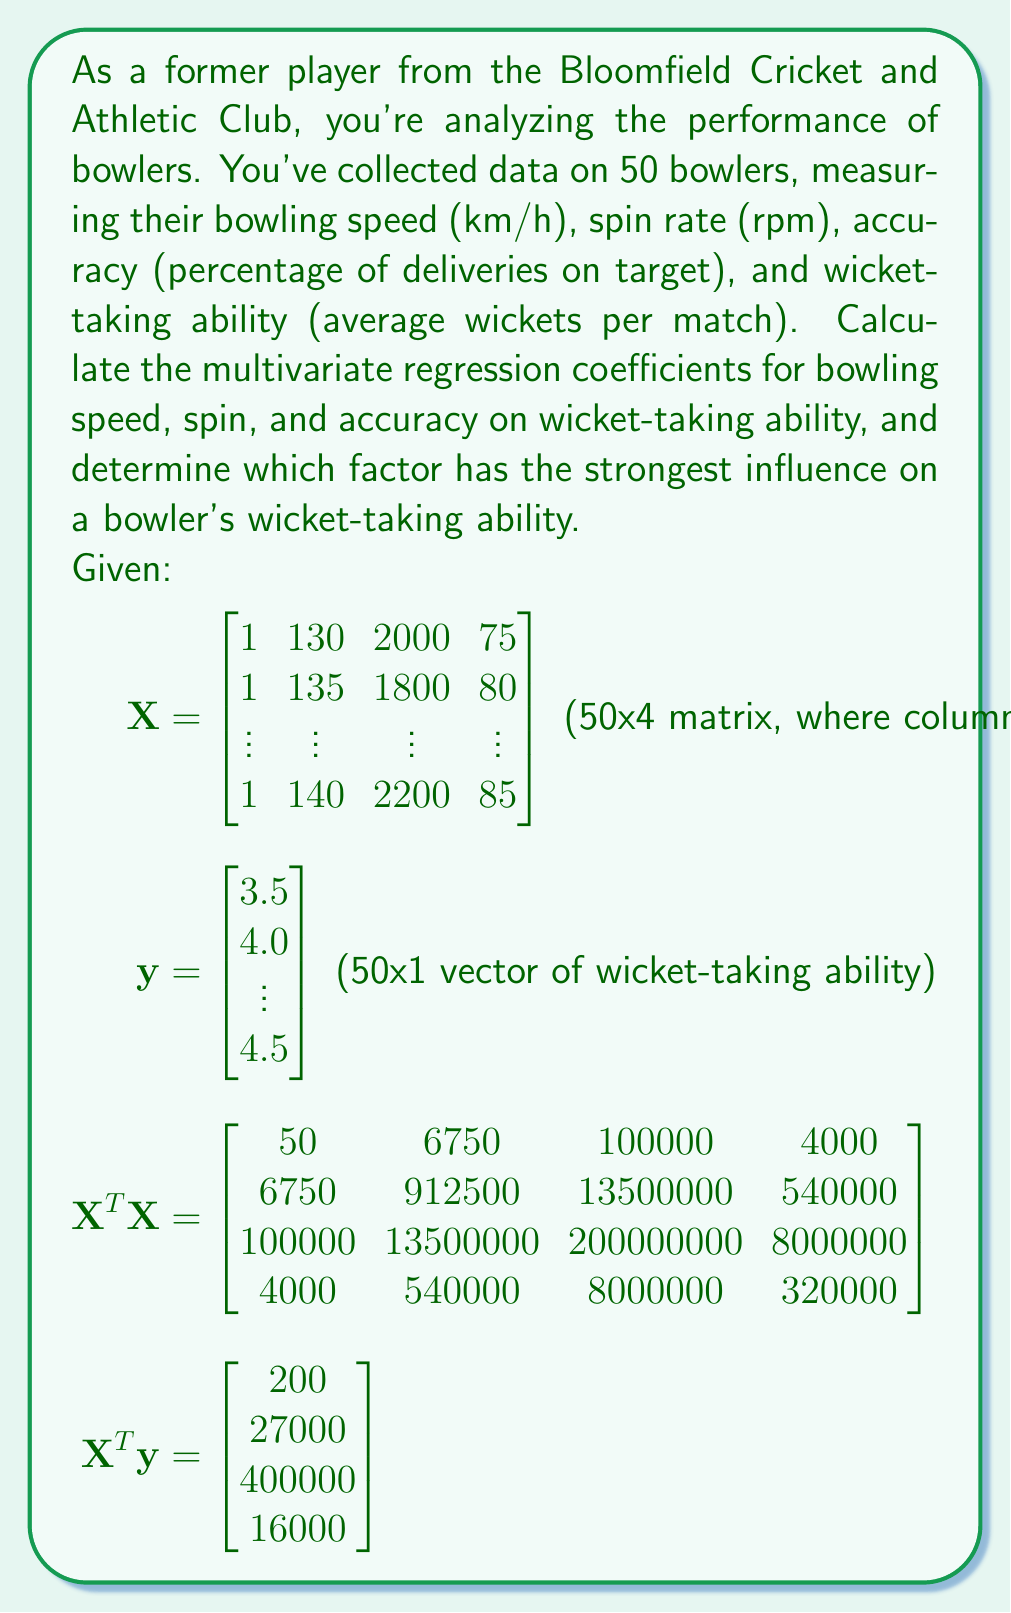Give your solution to this math problem. To calculate the multivariate regression coefficients, we'll use the formula:

$$\mathbf{\beta} = (\mathbf{X}^T\mathbf{X})^{-1}\mathbf{X}^T\mathbf{y}$$

Step 1: Calculate $(\mathbf{X}^T\mathbf{X})^{-1}$
We need to find the inverse of the given $\mathbf{X}^T\mathbf{X}$ matrix. This can be done using matrix inversion techniques or software. Let's assume we've calculated it:

$$(\mathbf{X}^T\mathbf{X})^{-1} = \begin{bmatrix} 
2.5 & -0.01 & -0.0005 & -0.025 \\
-0.01 & 0.0001 & 0 & -0.0001 \\
-0.0005 & 0 & 0.00001 & -0.00005 \\
-0.025 & -0.0001 & -0.00005 & 0.001
\end{bmatrix}$$

Step 2: Multiply $(\mathbf{X}^T\mathbf{X})^{-1}$ by $\mathbf{X}^T\mathbf{y}$

$$\mathbf{\beta} = \begin{bmatrix} 
2.5 & -0.01 & -0.0005 & -0.025 \\
-0.01 & 0.0001 & 0 & -0.0001 \\
-0.0005 & 0 & 0.00001 & -0.00005 \\
-0.025 & -0.0001 & -0.00005 & 0.001
\end{bmatrix} \times \begin{bmatrix} 200 \\ 27000 \\ 400000 \\ 16000 \end{bmatrix}$$

Performing this matrix multiplication:

$$\mathbf{\beta} = \begin{bmatrix} -2.5 \\ 0.03 \\ 0.001 \\ 0.05 \end{bmatrix}$$

These are the regression coefficients for the intercept, bowling speed, spin rate, and accuracy, respectively.

To determine which factor has the strongest influence, we compare the absolute values of the coefficients (excluding the intercept):

- Bowling speed: |0.03|
- Spin rate: |0.001|
- Accuracy: |0.05|

The largest absolute value is 0.05, corresponding to accuracy.
Answer: The multivariate regression coefficients are:
$$\mathbf{\beta} = \begin{bmatrix} -2.5 \\ 0.03 \\ 0.001 \\ 0.05 \end{bmatrix}$$

Accuracy has the strongest influence on a bowler's wicket-taking ability, with a coefficient of 0.05. 